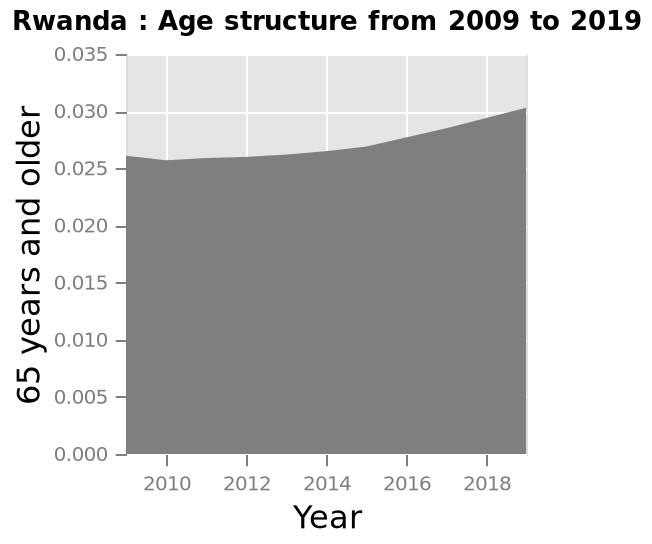<image>
What is the minimum value on the y-axis in the area graph depicting Rwanda's age structure from 2009 to 2019? The minimum value on the y-axis in the area graph depicting Rwanda's age structure from 2009 to 2019 is 0.000. Did the proportion of over-65s decrease or increase during the given period? The proportion of over-65s increased during the given period. Offer a thorough analysis of the image. The proportion of over-65s grew during the given period. 